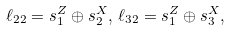<formula> <loc_0><loc_0><loc_500><loc_500>\ell _ { 2 2 } = s _ { 1 } ^ { Z } \oplus s _ { 2 } ^ { X } , \, \ell _ { 3 2 } = s _ { 1 } ^ { Z } \oplus s _ { 3 } ^ { X } ,</formula> 